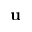<formula> <loc_0><loc_0><loc_500><loc_500>u</formula> 